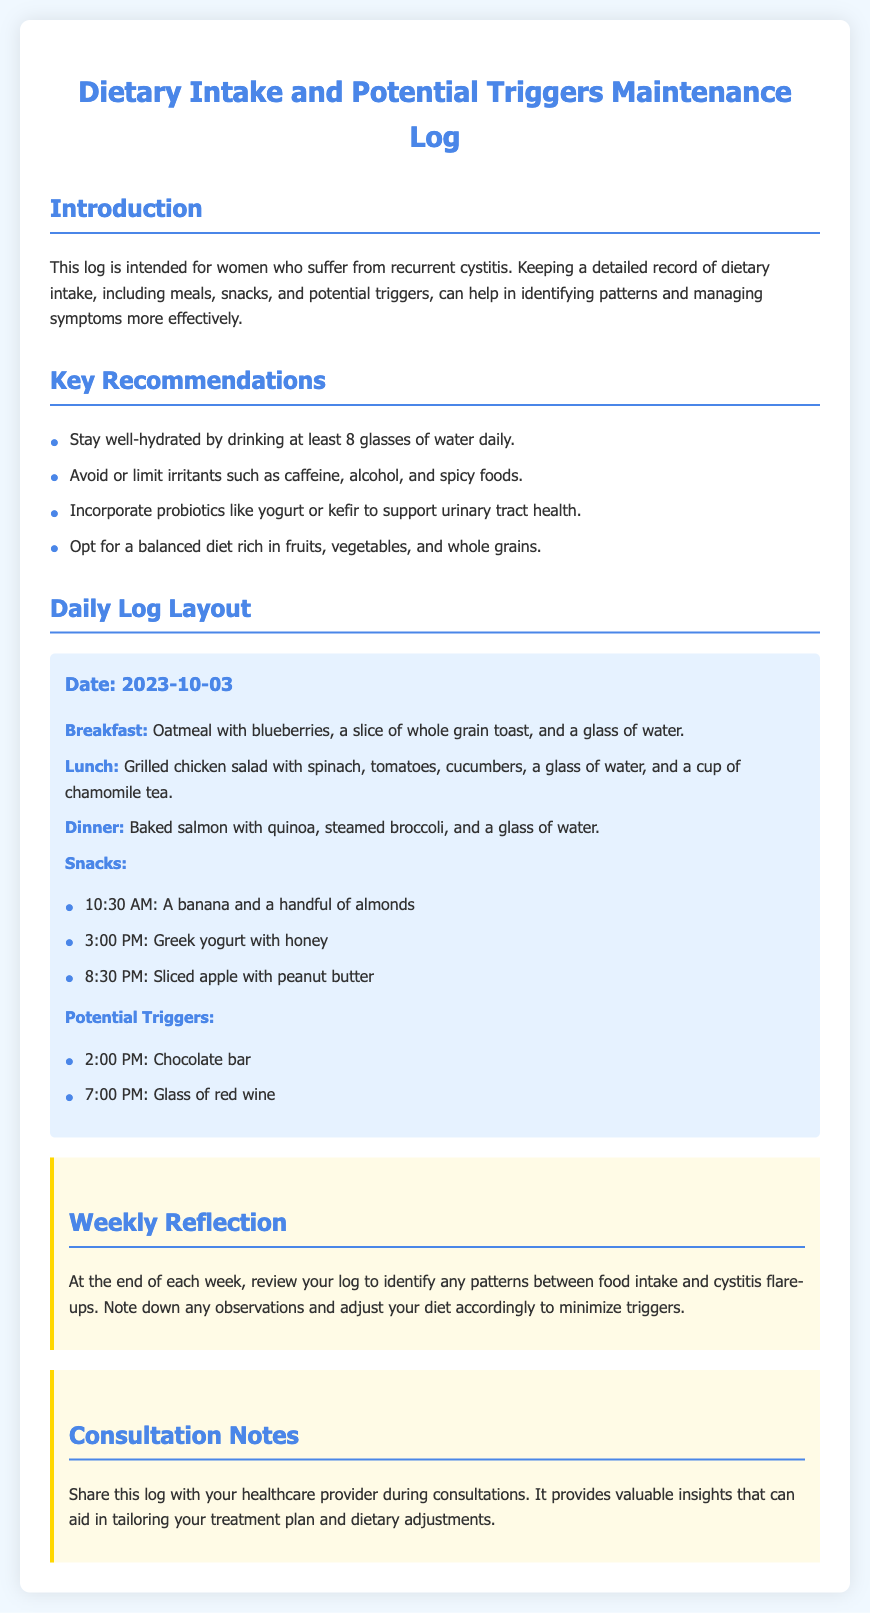what is the date of the log entry? The date is specified at the beginning of the log entry to indicate when the dietary intake was recorded.
Answer: 2023-10-03 what meal included a glass of chamomile tea? This detail is recorded under the lunch section of the log entry, which specifies what was consumed.
Answer: Lunch how many snacks are listed? The snacks section contains a list of items that were consumed between main meals, allowing for easy counting.
Answer: 3 which beverage was consumed with dinner? The drink associated with the dinner meal is specified in the log entry under that meal's details.
Answer: Water how many potential triggers are noted? The potential triggers are explicitly listed, allowing for a quick tally of their number.
Answer: 2 what type of salad was eaten for lunch? The salad description provides details about its contents and contributes to understanding the meal choice.
Answer: Grilled chicken salad was there any alcohol consumed? Alcohol consumption is directly noted in the potential triggers section of the log, making this easy to identify.
Answer: Yes what is recommended to support urinary tract health? The key recommendations section provides insights into dietary choices that can help manage symptoms effectively.
Answer: Probiotics what meal included quinoa? The meal details allow one to identify which meal contained this specific grain that is mentioned.
Answer: Dinner 